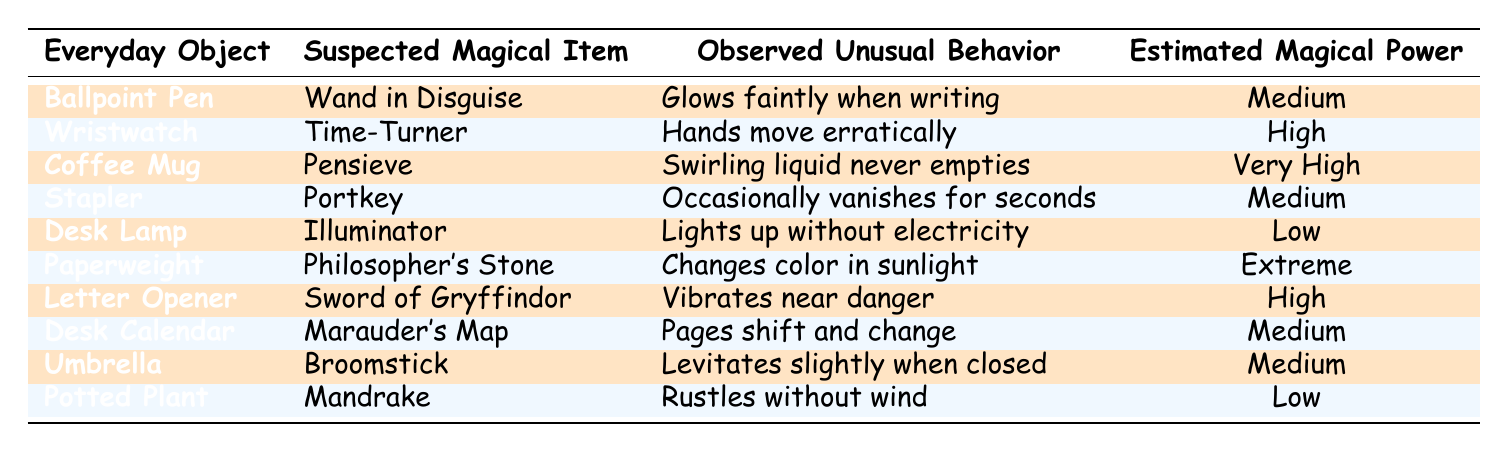What is the estimated magical power of the Coffee Mug? The Coffee Mug is listed in the table with an estimated magical power of "Very High."
Answer: Very High Which everyday object has the highest estimated magical power? The Paperweight has the highest estimated magical power, classified as "Extreme."
Answer: Extreme Does the Desk Lamp have any unusual behavior observed? Yes, the Desk Lamp is noted to light up without electricity, which is unusual behavior for a regular desk lamp.
Answer: Yes What unusual behavior does the Wristwatch exhibit? The Wristwatch exhibits erratic movement of the hands, which is the unusual behavior observed as documented in the table.
Answer: Hands move erratically Which two objects are categorized with medium estimated magical power? The objects categorized with medium estimated magical power are the Ballpoint Pen and the Stapler.
Answer: Ballpoint Pen, Stapler If we add up the estimated magical powers classified as High and Very High, how many items would fall under that classification? There are 3 items with High (Wristwatch, Letter Opener) and 1 item with Very High (Coffee Mug), totaling four items.
Answer: 4 What is the unusual behavior of the Potted Plant? The Potted Plant is observed to rustle without any wind, which is its unusual behavior.
Answer: Rustles without wind Is there an item in the table that displays an unusual behavior related to vanishing? Yes, the Stapler is noted to occasionally vanish for seconds, which is related to vanishing behavior.
Answer: Yes What is the common unusual behavior observed in items categorized with low magical power? Both the Desk Lamp and Potted Plant exhibit unusual behavior that doesn't indicate increased magical potency, such as lighting up without power and rustling without wind, respectively.
Answer: Lighting up without power and rustling without wind Which suspected magical item is represented by the Paperweight, and what is its corresponding unusual behavior? The Paperweight is suspected to be the Philosopher's Stone, and its unusual behavior is that it changes color in sunlight.
Answer: Philosopher's Stone; changes color in sunlight 